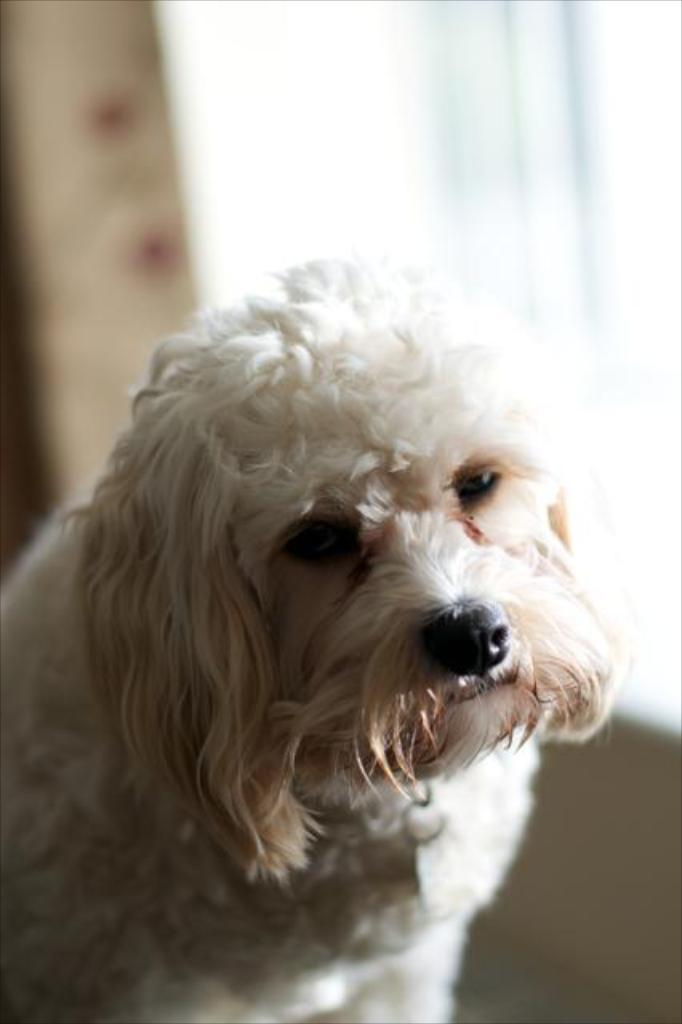What color is the dog in the image? The dog is white in color. How many toes does the bell on the dog's collar have in the image? There is no bell present on the dog's collar in the image, and therefore no toes can be counted. 